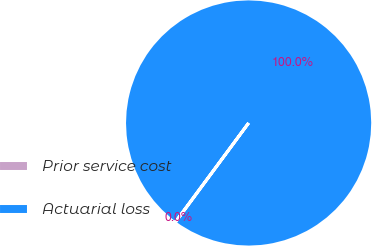<chart> <loc_0><loc_0><loc_500><loc_500><pie_chart><fcel>Prior service cost<fcel>Actuarial loss<nl><fcel>0.04%<fcel>99.96%<nl></chart> 